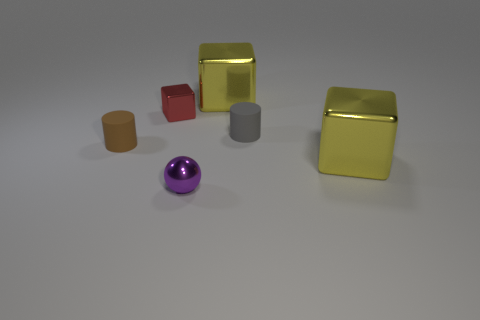Add 3 large cubes. How many objects exist? 9 Subtract all cylinders. How many objects are left? 4 Add 3 large red rubber cylinders. How many large red rubber cylinders exist? 3 Subtract 0 gray spheres. How many objects are left? 6 Subtract all large gray shiny blocks. Subtract all yellow shiny objects. How many objects are left? 4 Add 4 yellow cubes. How many yellow cubes are left? 6 